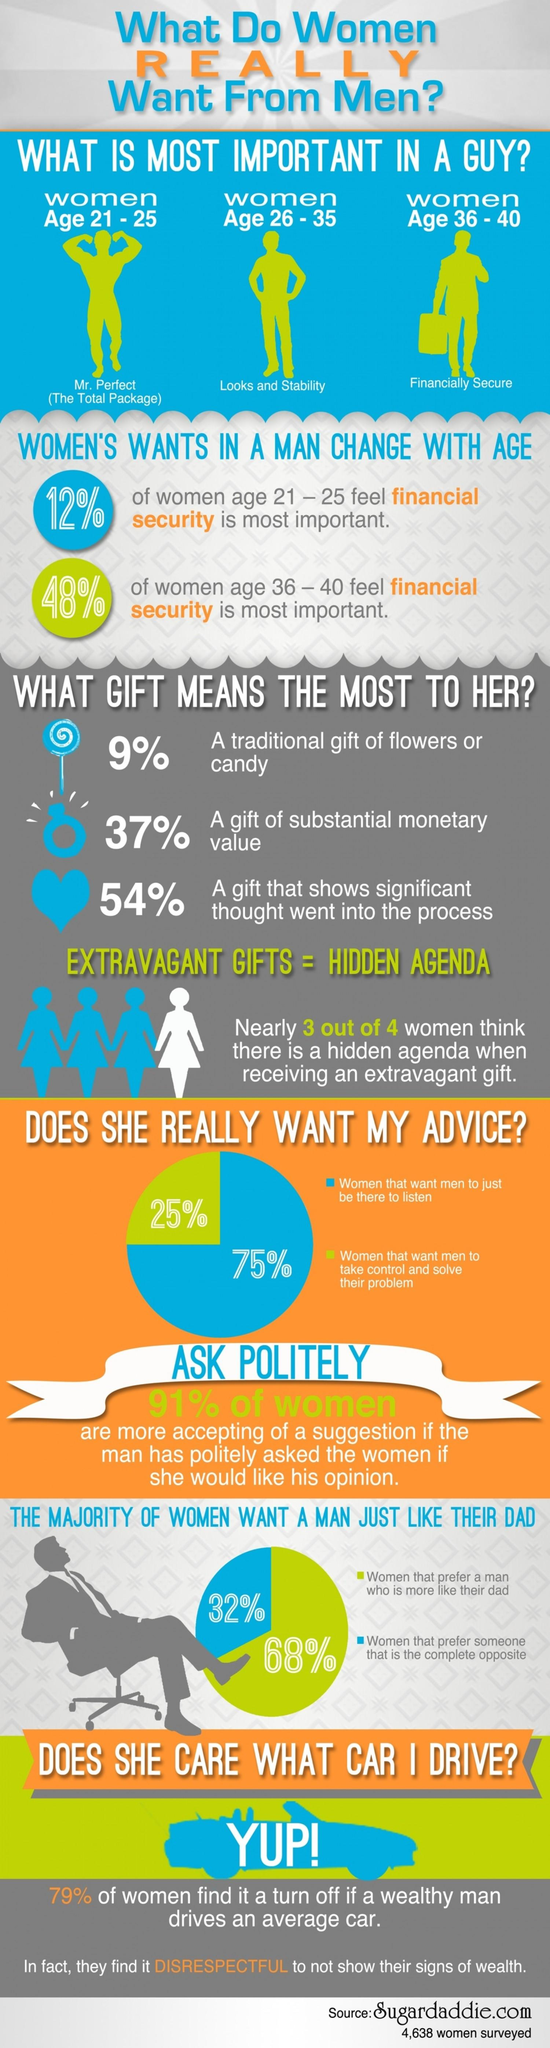Identify some key points in this picture. According to a survey, 68% of women prefer a man who is more like their dad. According to a survey of women aged 26-35 years, they place a high value on both physical appearance and stability in men. According to the survey, women in the age group of 36-40 years view financial stability as the most important trait in a potential partner. According to the survey, 25% of women prefer men to take control and solve their problems. According to a survey, 75% of women believe that men should just be there to listen. 